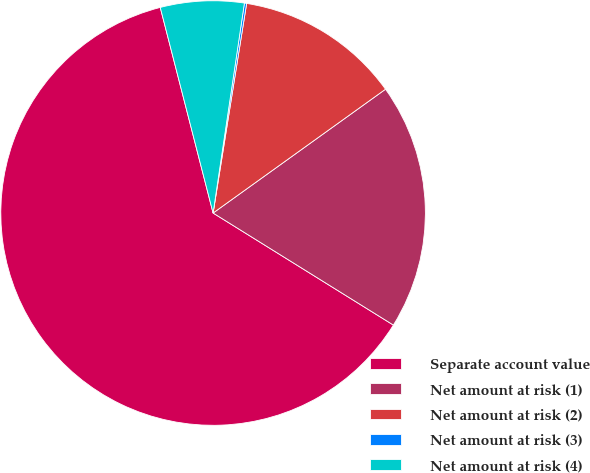Convert chart. <chart><loc_0><loc_0><loc_500><loc_500><pie_chart><fcel>Separate account value<fcel>Net amount at risk (1)<fcel>Net amount at risk (2)<fcel>Net amount at risk (3)<fcel>Net amount at risk (4)<nl><fcel>62.14%<fcel>18.76%<fcel>12.56%<fcel>0.17%<fcel>6.36%<nl></chart> 